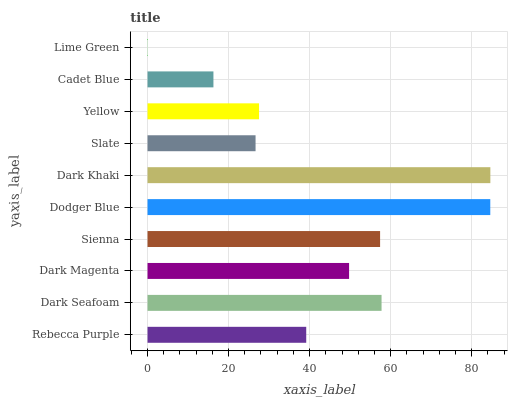Is Lime Green the minimum?
Answer yes or no. Yes. Is Dark Khaki the maximum?
Answer yes or no. Yes. Is Dark Seafoam the minimum?
Answer yes or no. No. Is Dark Seafoam the maximum?
Answer yes or no. No. Is Dark Seafoam greater than Rebecca Purple?
Answer yes or no. Yes. Is Rebecca Purple less than Dark Seafoam?
Answer yes or no. Yes. Is Rebecca Purple greater than Dark Seafoam?
Answer yes or no. No. Is Dark Seafoam less than Rebecca Purple?
Answer yes or no. No. Is Dark Magenta the high median?
Answer yes or no. Yes. Is Rebecca Purple the low median?
Answer yes or no. Yes. Is Dark Khaki the high median?
Answer yes or no. No. Is Dark Khaki the low median?
Answer yes or no. No. 